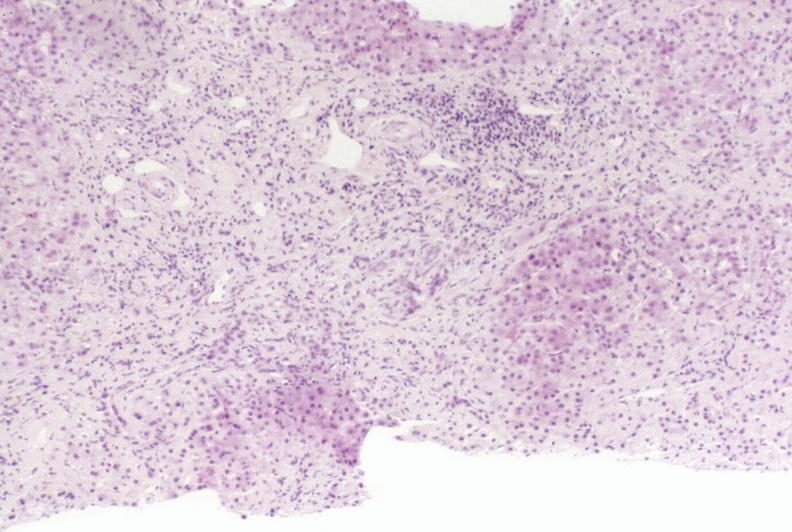s siamese twins present?
Answer the question using a single word or phrase. No 